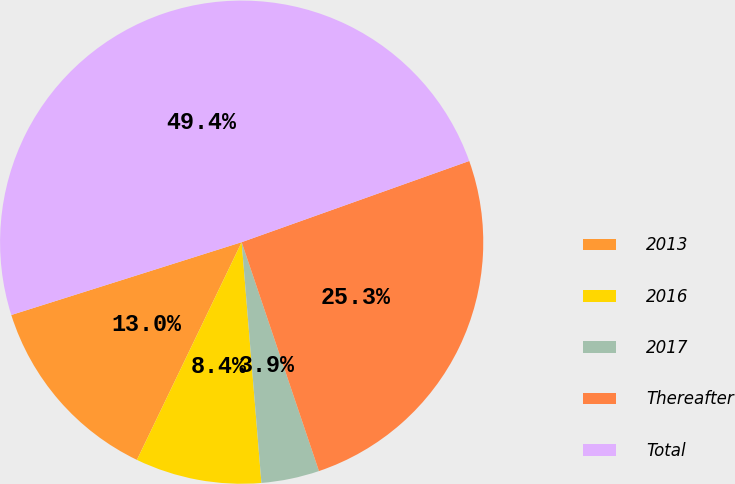<chart> <loc_0><loc_0><loc_500><loc_500><pie_chart><fcel>2013<fcel>2016<fcel>2017<fcel>Thereafter<fcel>Total<nl><fcel>12.99%<fcel>8.44%<fcel>3.88%<fcel>25.27%<fcel>49.42%<nl></chart> 